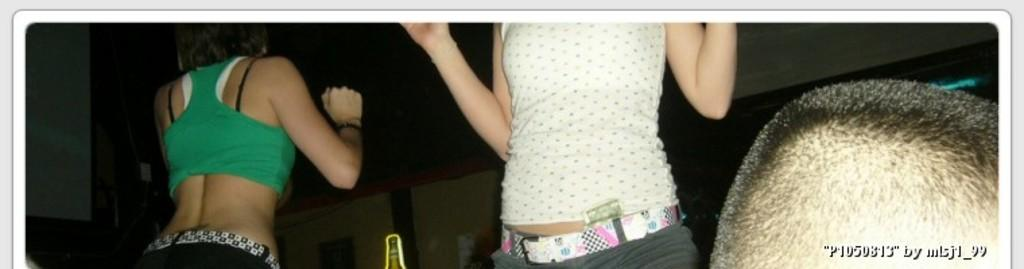How many people are in the image? There are three persons in the image. Can you describe any text that is visible in the image? Yes, there is text in the bottom right of the image. What type of zipper can be seen on the person's clothing in the image? There is no zipper visible on any of the persons' clothing in the image. What language is the text written in, in the bottom right of the image? The provided facts do not mention the language of the text, so it cannot be determined from the image. 